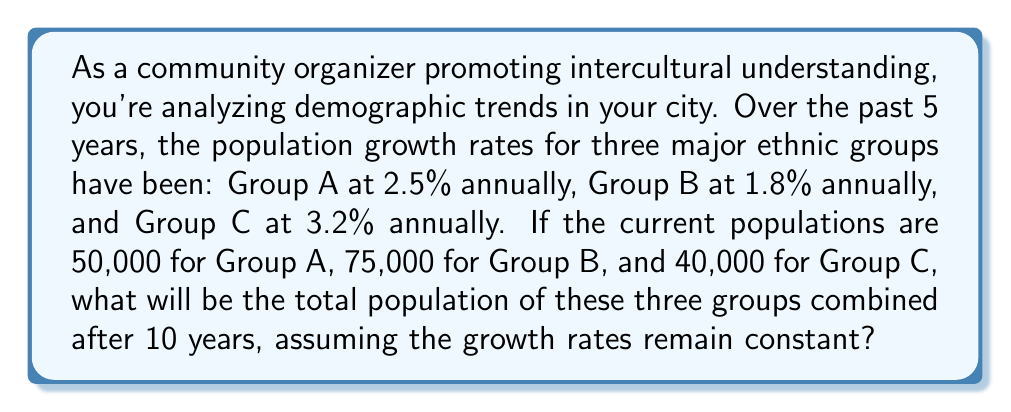Solve this math problem. To solve this problem, we'll use the compound interest formula for population growth:

$P_t = P_0(1 + r)^t$

Where:
$P_t$ = Final population
$P_0$ = Initial population
$r$ = Annual growth rate (as a decimal)
$t$ = Time in years

Step 1: Calculate the population of Group A after 10 years
$P_A = 50,000(1 + 0.025)^{10} = 50,000(1.025)^{10} = 64,004.42$

Step 2: Calculate the population of Group B after 10 years
$P_B = 75,000(1 + 0.018)^{10} = 75,000(1.018)^{10} = 89,472.60$

Step 3: Calculate the population of Group C after 10 years
$P_C = 40,000(1 + 0.032)^{10} = 40,000(1.032)^{10} = 54,784.38$

Step 4: Sum the populations of all three groups
Total population = $P_A + P_B + P_C$
$= 64,004.42 + 89,472.60 + 54,784.38$
$= 208,261.40$

Step 5: Round to the nearest whole number
Total population ≈ 208,261
Answer: 208,261 